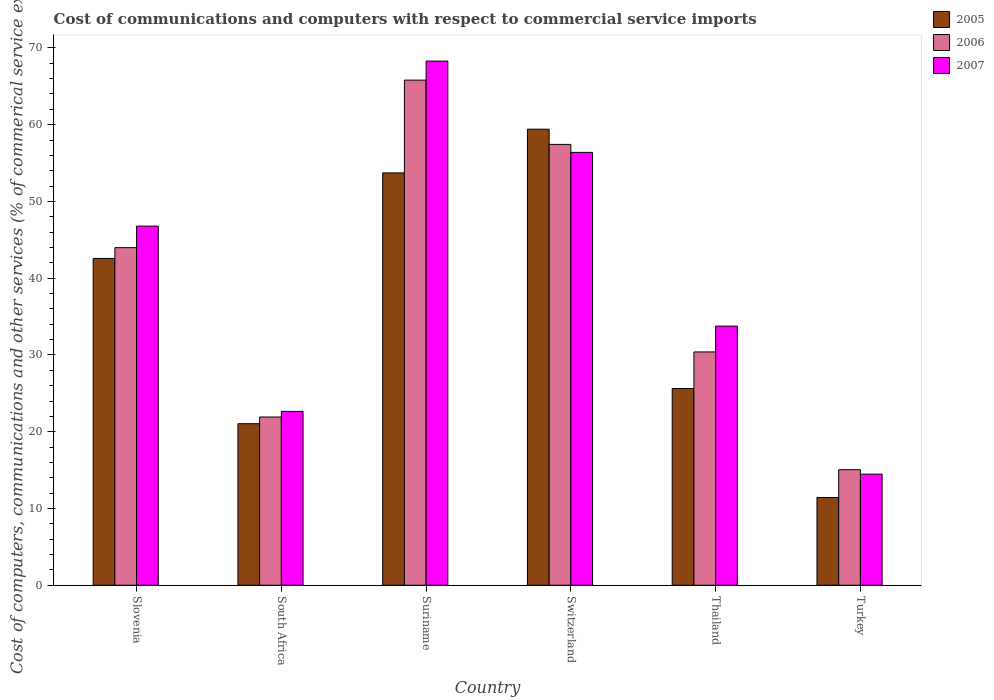What is the label of the 6th group of bars from the left?
Provide a succinct answer. Turkey. In how many cases, is the number of bars for a given country not equal to the number of legend labels?
Your answer should be very brief. 0. What is the cost of communications and computers in 2007 in Suriname?
Provide a succinct answer. 68.28. Across all countries, what is the maximum cost of communications and computers in 2007?
Ensure brevity in your answer.  68.28. Across all countries, what is the minimum cost of communications and computers in 2006?
Keep it short and to the point. 15.05. In which country was the cost of communications and computers in 2006 maximum?
Keep it short and to the point. Suriname. In which country was the cost of communications and computers in 2007 minimum?
Your answer should be very brief. Turkey. What is the total cost of communications and computers in 2007 in the graph?
Your response must be concise. 242.33. What is the difference between the cost of communications and computers in 2005 in Slovenia and that in Turkey?
Ensure brevity in your answer.  31.15. What is the difference between the cost of communications and computers in 2005 in South Africa and the cost of communications and computers in 2006 in Thailand?
Offer a very short reply. -9.35. What is the average cost of communications and computers in 2007 per country?
Your answer should be very brief. 40.39. What is the difference between the cost of communications and computers of/in 2005 and cost of communications and computers of/in 2007 in South Africa?
Offer a very short reply. -1.6. In how many countries, is the cost of communications and computers in 2007 greater than 64 %?
Your answer should be compact. 1. What is the ratio of the cost of communications and computers in 2006 in Slovenia to that in Turkey?
Ensure brevity in your answer.  2.92. Is the cost of communications and computers in 2007 in Slovenia less than that in Turkey?
Provide a short and direct response. No. Is the difference between the cost of communications and computers in 2005 in Slovenia and Thailand greater than the difference between the cost of communications and computers in 2007 in Slovenia and Thailand?
Your response must be concise. Yes. What is the difference between the highest and the second highest cost of communications and computers in 2006?
Ensure brevity in your answer.  21.82. What is the difference between the highest and the lowest cost of communications and computers in 2005?
Your answer should be very brief. 47.98. In how many countries, is the cost of communications and computers in 2007 greater than the average cost of communications and computers in 2007 taken over all countries?
Offer a terse response. 3. Is it the case that in every country, the sum of the cost of communications and computers in 2006 and cost of communications and computers in 2007 is greater than the cost of communications and computers in 2005?
Your answer should be compact. Yes. How many bars are there?
Make the answer very short. 18. Does the graph contain grids?
Ensure brevity in your answer.  No. Where does the legend appear in the graph?
Offer a very short reply. Top right. What is the title of the graph?
Make the answer very short. Cost of communications and computers with respect to commercial service imports. Does "1961" appear as one of the legend labels in the graph?
Your answer should be very brief. No. What is the label or title of the X-axis?
Your response must be concise. Country. What is the label or title of the Y-axis?
Make the answer very short. Cost of computers, communications and other services (% of commerical service exports). What is the Cost of computers, communications and other services (% of commerical service exports) in 2005 in Slovenia?
Provide a succinct answer. 42.57. What is the Cost of computers, communications and other services (% of commerical service exports) in 2006 in Slovenia?
Your answer should be very brief. 43.98. What is the Cost of computers, communications and other services (% of commerical service exports) in 2007 in Slovenia?
Offer a terse response. 46.78. What is the Cost of computers, communications and other services (% of commerical service exports) of 2005 in South Africa?
Keep it short and to the point. 21.04. What is the Cost of computers, communications and other services (% of commerical service exports) of 2006 in South Africa?
Your answer should be compact. 21.92. What is the Cost of computers, communications and other services (% of commerical service exports) in 2007 in South Africa?
Your answer should be compact. 22.65. What is the Cost of computers, communications and other services (% of commerical service exports) of 2005 in Suriname?
Provide a succinct answer. 53.71. What is the Cost of computers, communications and other services (% of commerical service exports) of 2006 in Suriname?
Your response must be concise. 65.8. What is the Cost of computers, communications and other services (% of commerical service exports) of 2007 in Suriname?
Give a very brief answer. 68.28. What is the Cost of computers, communications and other services (% of commerical service exports) of 2005 in Switzerland?
Make the answer very short. 59.41. What is the Cost of computers, communications and other services (% of commerical service exports) in 2006 in Switzerland?
Your answer should be compact. 57.43. What is the Cost of computers, communications and other services (% of commerical service exports) in 2007 in Switzerland?
Make the answer very short. 56.39. What is the Cost of computers, communications and other services (% of commerical service exports) of 2005 in Thailand?
Give a very brief answer. 25.63. What is the Cost of computers, communications and other services (% of commerical service exports) of 2006 in Thailand?
Offer a very short reply. 30.39. What is the Cost of computers, communications and other services (% of commerical service exports) in 2007 in Thailand?
Make the answer very short. 33.76. What is the Cost of computers, communications and other services (% of commerical service exports) in 2005 in Turkey?
Your response must be concise. 11.43. What is the Cost of computers, communications and other services (% of commerical service exports) in 2006 in Turkey?
Keep it short and to the point. 15.05. What is the Cost of computers, communications and other services (% of commerical service exports) in 2007 in Turkey?
Provide a short and direct response. 14.47. Across all countries, what is the maximum Cost of computers, communications and other services (% of commerical service exports) in 2005?
Your answer should be compact. 59.41. Across all countries, what is the maximum Cost of computers, communications and other services (% of commerical service exports) of 2006?
Your answer should be very brief. 65.8. Across all countries, what is the maximum Cost of computers, communications and other services (% of commerical service exports) of 2007?
Your response must be concise. 68.28. Across all countries, what is the minimum Cost of computers, communications and other services (% of commerical service exports) of 2005?
Offer a terse response. 11.43. Across all countries, what is the minimum Cost of computers, communications and other services (% of commerical service exports) of 2006?
Your answer should be compact. 15.05. Across all countries, what is the minimum Cost of computers, communications and other services (% of commerical service exports) of 2007?
Give a very brief answer. 14.47. What is the total Cost of computers, communications and other services (% of commerical service exports) of 2005 in the graph?
Make the answer very short. 213.79. What is the total Cost of computers, communications and other services (% of commerical service exports) in 2006 in the graph?
Your answer should be very brief. 234.57. What is the total Cost of computers, communications and other services (% of commerical service exports) in 2007 in the graph?
Keep it short and to the point. 242.33. What is the difference between the Cost of computers, communications and other services (% of commerical service exports) in 2005 in Slovenia and that in South Africa?
Offer a very short reply. 21.53. What is the difference between the Cost of computers, communications and other services (% of commerical service exports) of 2006 in Slovenia and that in South Africa?
Provide a short and direct response. 22.06. What is the difference between the Cost of computers, communications and other services (% of commerical service exports) in 2007 in Slovenia and that in South Africa?
Provide a short and direct response. 24.14. What is the difference between the Cost of computers, communications and other services (% of commerical service exports) in 2005 in Slovenia and that in Suriname?
Provide a short and direct response. -11.14. What is the difference between the Cost of computers, communications and other services (% of commerical service exports) in 2006 in Slovenia and that in Suriname?
Give a very brief answer. -21.82. What is the difference between the Cost of computers, communications and other services (% of commerical service exports) in 2007 in Slovenia and that in Suriname?
Ensure brevity in your answer.  -21.5. What is the difference between the Cost of computers, communications and other services (% of commerical service exports) in 2005 in Slovenia and that in Switzerland?
Give a very brief answer. -16.83. What is the difference between the Cost of computers, communications and other services (% of commerical service exports) of 2006 in Slovenia and that in Switzerland?
Keep it short and to the point. -13.45. What is the difference between the Cost of computers, communications and other services (% of commerical service exports) of 2007 in Slovenia and that in Switzerland?
Provide a short and direct response. -9.61. What is the difference between the Cost of computers, communications and other services (% of commerical service exports) in 2005 in Slovenia and that in Thailand?
Offer a terse response. 16.94. What is the difference between the Cost of computers, communications and other services (% of commerical service exports) in 2006 in Slovenia and that in Thailand?
Your answer should be very brief. 13.59. What is the difference between the Cost of computers, communications and other services (% of commerical service exports) of 2007 in Slovenia and that in Thailand?
Make the answer very short. 13.02. What is the difference between the Cost of computers, communications and other services (% of commerical service exports) of 2005 in Slovenia and that in Turkey?
Offer a very short reply. 31.15. What is the difference between the Cost of computers, communications and other services (% of commerical service exports) of 2006 in Slovenia and that in Turkey?
Your answer should be compact. 28.93. What is the difference between the Cost of computers, communications and other services (% of commerical service exports) of 2007 in Slovenia and that in Turkey?
Give a very brief answer. 32.31. What is the difference between the Cost of computers, communications and other services (% of commerical service exports) in 2005 in South Africa and that in Suriname?
Your answer should be compact. -32.67. What is the difference between the Cost of computers, communications and other services (% of commerical service exports) of 2006 in South Africa and that in Suriname?
Offer a terse response. -43.89. What is the difference between the Cost of computers, communications and other services (% of commerical service exports) of 2007 in South Africa and that in Suriname?
Your response must be concise. -45.64. What is the difference between the Cost of computers, communications and other services (% of commerical service exports) of 2005 in South Africa and that in Switzerland?
Make the answer very short. -38.37. What is the difference between the Cost of computers, communications and other services (% of commerical service exports) in 2006 in South Africa and that in Switzerland?
Your answer should be very brief. -35.51. What is the difference between the Cost of computers, communications and other services (% of commerical service exports) of 2007 in South Africa and that in Switzerland?
Offer a very short reply. -33.74. What is the difference between the Cost of computers, communications and other services (% of commerical service exports) of 2005 in South Africa and that in Thailand?
Provide a succinct answer. -4.59. What is the difference between the Cost of computers, communications and other services (% of commerical service exports) in 2006 in South Africa and that in Thailand?
Provide a succinct answer. -8.48. What is the difference between the Cost of computers, communications and other services (% of commerical service exports) in 2007 in South Africa and that in Thailand?
Your answer should be compact. -11.11. What is the difference between the Cost of computers, communications and other services (% of commerical service exports) in 2005 in South Africa and that in Turkey?
Your response must be concise. 9.62. What is the difference between the Cost of computers, communications and other services (% of commerical service exports) in 2006 in South Africa and that in Turkey?
Provide a succinct answer. 6.87. What is the difference between the Cost of computers, communications and other services (% of commerical service exports) of 2007 in South Africa and that in Turkey?
Your response must be concise. 8.18. What is the difference between the Cost of computers, communications and other services (% of commerical service exports) in 2005 in Suriname and that in Switzerland?
Give a very brief answer. -5.69. What is the difference between the Cost of computers, communications and other services (% of commerical service exports) of 2006 in Suriname and that in Switzerland?
Give a very brief answer. 8.37. What is the difference between the Cost of computers, communications and other services (% of commerical service exports) in 2007 in Suriname and that in Switzerland?
Give a very brief answer. 11.89. What is the difference between the Cost of computers, communications and other services (% of commerical service exports) of 2005 in Suriname and that in Thailand?
Keep it short and to the point. 28.09. What is the difference between the Cost of computers, communications and other services (% of commerical service exports) in 2006 in Suriname and that in Thailand?
Offer a terse response. 35.41. What is the difference between the Cost of computers, communications and other services (% of commerical service exports) of 2007 in Suriname and that in Thailand?
Your answer should be very brief. 34.52. What is the difference between the Cost of computers, communications and other services (% of commerical service exports) of 2005 in Suriname and that in Turkey?
Provide a short and direct response. 42.29. What is the difference between the Cost of computers, communications and other services (% of commerical service exports) in 2006 in Suriname and that in Turkey?
Offer a very short reply. 50.75. What is the difference between the Cost of computers, communications and other services (% of commerical service exports) of 2007 in Suriname and that in Turkey?
Keep it short and to the point. 53.81. What is the difference between the Cost of computers, communications and other services (% of commerical service exports) in 2005 in Switzerland and that in Thailand?
Your response must be concise. 33.78. What is the difference between the Cost of computers, communications and other services (% of commerical service exports) in 2006 in Switzerland and that in Thailand?
Ensure brevity in your answer.  27.04. What is the difference between the Cost of computers, communications and other services (% of commerical service exports) in 2007 in Switzerland and that in Thailand?
Give a very brief answer. 22.63. What is the difference between the Cost of computers, communications and other services (% of commerical service exports) of 2005 in Switzerland and that in Turkey?
Keep it short and to the point. 47.98. What is the difference between the Cost of computers, communications and other services (% of commerical service exports) in 2006 in Switzerland and that in Turkey?
Keep it short and to the point. 42.38. What is the difference between the Cost of computers, communications and other services (% of commerical service exports) of 2007 in Switzerland and that in Turkey?
Your answer should be compact. 41.92. What is the difference between the Cost of computers, communications and other services (% of commerical service exports) of 2005 in Thailand and that in Turkey?
Provide a succinct answer. 14.2. What is the difference between the Cost of computers, communications and other services (% of commerical service exports) of 2006 in Thailand and that in Turkey?
Keep it short and to the point. 15.34. What is the difference between the Cost of computers, communications and other services (% of commerical service exports) of 2007 in Thailand and that in Turkey?
Your response must be concise. 19.29. What is the difference between the Cost of computers, communications and other services (% of commerical service exports) in 2005 in Slovenia and the Cost of computers, communications and other services (% of commerical service exports) in 2006 in South Africa?
Offer a terse response. 20.66. What is the difference between the Cost of computers, communications and other services (% of commerical service exports) in 2005 in Slovenia and the Cost of computers, communications and other services (% of commerical service exports) in 2007 in South Africa?
Your answer should be very brief. 19.93. What is the difference between the Cost of computers, communications and other services (% of commerical service exports) of 2006 in Slovenia and the Cost of computers, communications and other services (% of commerical service exports) of 2007 in South Africa?
Your response must be concise. 21.33. What is the difference between the Cost of computers, communications and other services (% of commerical service exports) in 2005 in Slovenia and the Cost of computers, communications and other services (% of commerical service exports) in 2006 in Suriname?
Provide a short and direct response. -23.23. What is the difference between the Cost of computers, communications and other services (% of commerical service exports) of 2005 in Slovenia and the Cost of computers, communications and other services (% of commerical service exports) of 2007 in Suriname?
Your response must be concise. -25.71. What is the difference between the Cost of computers, communications and other services (% of commerical service exports) in 2006 in Slovenia and the Cost of computers, communications and other services (% of commerical service exports) in 2007 in Suriname?
Provide a succinct answer. -24.3. What is the difference between the Cost of computers, communications and other services (% of commerical service exports) of 2005 in Slovenia and the Cost of computers, communications and other services (% of commerical service exports) of 2006 in Switzerland?
Provide a short and direct response. -14.85. What is the difference between the Cost of computers, communications and other services (% of commerical service exports) of 2005 in Slovenia and the Cost of computers, communications and other services (% of commerical service exports) of 2007 in Switzerland?
Provide a short and direct response. -13.81. What is the difference between the Cost of computers, communications and other services (% of commerical service exports) in 2006 in Slovenia and the Cost of computers, communications and other services (% of commerical service exports) in 2007 in Switzerland?
Provide a succinct answer. -12.41. What is the difference between the Cost of computers, communications and other services (% of commerical service exports) of 2005 in Slovenia and the Cost of computers, communications and other services (% of commerical service exports) of 2006 in Thailand?
Give a very brief answer. 12.18. What is the difference between the Cost of computers, communications and other services (% of commerical service exports) in 2005 in Slovenia and the Cost of computers, communications and other services (% of commerical service exports) in 2007 in Thailand?
Give a very brief answer. 8.82. What is the difference between the Cost of computers, communications and other services (% of commerical service exports) of 2006 in Slovenia and the Cost of computers, communications and other services (% of commerical service exports) of 2007 in Thailand?
Ensure brevity in your answer.  10.22. What is the difference between the Cost of computers, communications and other services (% of commerical service exports) of 2005 in Slovenia and the Cost of computers, communications and other services (% of commerical service exports) of 2006 in Turkey?
Provide a succinct answer. 27.52. What is the difference between the Cost of computers, communications and other services (% of commerical service exports) of 2005 in Slovenia and the Cost of computers, communications and other services (% of commerical service exports) of 2007 in Turkey?
Ensure brevity in your answer.  28.1. What is the difference between the Cost of computers, communications and other services (% of commerical service exports) of 2006 in Slovenia and the Cost of computers, communications and other services (% of commerical service exports) of 2007 in Turkey?
Your response must be concise. 29.51. What is the difference between the Cost of computers, communications and other services (% of commerical service exports) in 2005 in South Africa and the Cost of computers, communications and other services (% of commerical service exports) in 2006 in Suriname?
Your answer should be compact. -44.76. What is the difference between the Cost of computers, communications and other services (% of commerical service exports) in 2005 in South Africa and the Cost of computers, communications and other services (% of commerical service exports) in 2007 in Suriname?
Give a very brief answer. -47.24. What is the difference between the Cost of computers, communications and other services (% of commerical service exports) in 2006 in South Africa and the Cost of computers, communications and other services (% of commerical service exports) in 2007 in Suriname?
Keep it short and to the point. -46.37. What is the difference between the Cost of computers, communications and other services (% of commerical service exports) in 2005 in South Africa and the Cost of computers, communications and other services (% of commerical service exports) in 2006 in Switzerland?
Ensure brevity in your answer.  -36.39. What is the difference between the Cost of computers, communications and other services (% of commerical service exports) of 2005 in South Africa and the Cost of computers, communications and other services (% of commerical service exports) of 2007 in Switzerland?
Provide a succinct answer. -35.35. What is the difference between the Cost of computers, communications and other services (% of commerical service exports) of 2006 in South Africa and the Cost of computers, communications and other services (% of commerical service exports) of 2007 in Switzerland?
Make the answer very short. -34.47. What is the difference between the Cost of computers, communications and other services (% of commerical service exports) in 2005 in South Africa and the Cost of computers, communications and other services (% of commerical service exports) in 2006 in Thailand?
Offer a terse response. -9.35. What is the difference between the Cost of computers, communications and other services (% of commerical service exports) in 2005 in South Africa and the Cost of computers, communications and other services (% of commerical service exports) in 2007 in Thailand?
Keep it short and to the point. -12.72. What is the difference between the Cost of computers, communications and other services (% of commerical service exports) of 2006 in South Africa and the Cost of computers, communications and other services (% of commerical service exports) of 2007 in Thailand?
Make the answer very short. -11.84. What is the difference between the Cost of computers, communications and other services (% of commerical service exports) of 2005 in South Africa and the Cost of computers, communications and other services (% of commerical service exports) of 2006 in Turkey?
Your response must be concise. 5.99. What is the difference between the Cost of computers, communications and other services (% of commerical service exports) of 2005 in South Africa and the Cost of computers, communications and other services (% of commerical service exports) of 2007 in Turkey?
Ensure brevity in your answer.  6.57. What is the difference between the Cost of computers, communications and other services (% of commerical service exports) of 2006 in South Africa and the Cost of computers, communications and other services (% of commerical service exports) of 2007 in Turkey?
Give a very brief answer. 7.45. What is the difference between the Cost of computers, communications and other services (% of commerical service exports) of 2005 in Suriname and the Cost of computers, communications and other services (% of commerical service exports) of 2006 in Switzerland?
Ensure brevity in your answer.  -3.71. What is the difference between the Cost of computers, communications and other services (% of commerical service exports) in 2005 in Suriname and the Cost of computers, communications and other services (% of commerical service exports) in 2007 in Switzerland?
Your response must be concise. -2.67. What is the difference between the Cost of computers, communications and other services (% of commerical service exports) of 2006 in Suriname and the Cost of computers, communications and other services (% of commerical service exports) of 2007 in Switzerland?
Your response must be concise. 9.41. What is the difference between the Cost of computers, communications and other services (% of commerical service exports) of 2005 in Suriname and the Cost of computers, communications and other services (% of commerical service exports) of 2006 in Thailand?
Offer a very short reply. 23.32. What is the difference between the Cost of computers, communications and other services (% of commerical service exports) in 2005 in Suriname and the Cost of computers, communications and other services (% of commerical service exports) in 2007 in Thailand?
Make the answer very short. 19.96. What is the difference between the Cost of computers, communications and other services (% of commerical service exports) in 2006 in Suriname and the Cost of computers, communications and other services (% of commerical service exports) in 2007 in Thailand?
Your response must be concise. 32.04. What is the difference between the Cost of computers, communications and other services (% of commerical service exports) in 2005 in Suriname and the Cost of computers, communications and other services (% of commerical service exports) in 2006 in Turkey?
Your response must be concise. 38.67. What is the difference between the Cost of computers, communications and other services (% of commerical service exports) of 2005 in Suriname and the Cost of computers, communications and other services (% of commerical service exports) of 2007 in Turkey?
Your response must be concise. 39.24. What is the difference between the Cost of computers, communications and other services (% of commerical service exports) of 2006 in Suriname and the Cost of computers, communications and other services (% of commerical service exports) of 2007 in Turkey?
Your response must be concise. 51.33. What is the difference between the Cost of computers, communications and other services (% of commerical service exports) of 2005 in Switzerland and the Cost of computers, communications and other services (% of commerical service exports) of 2006 in Thailand?
Offer a very short reply. 29.01. What is the difference between the Cost of computers, communications and other services (% of commerical service exports) in 2005 in Switzerland and the Cost of computers, communications and other services (% of commerical service exports) in 2007 in Thailand?
Provide a short and direct response. 25.65. What is the difference between the Cost of computers, communications and other services (% of commerical service exports) in 2006 in Switzerland and the Cost of computers, communications and other services (% of commerical service exports) in 2007 in Thailand?
Provide a short and direct response. 23.67. What is the difference between the Cost of computers, communications and other services (% of commerical service exports) of 2005 in Switzerland and the Cost of computers, communications and other services (% of commerical service exports) of 2006 in Turkey?
Make the answer very short. 44.36. What is the difference between the Cost of computers, communications and other services (% of commerical service exports) in 2005 in Switzerland and the Cost of computers, communications and other services (% of commerical service exports) in 2007 in Turkey?
Offer a very short reply. 44.94. What is the difference between the Cost of computers, communications and other services (% of commerical service exports) of 2006 in Switzerland and the Cost of computers, communications and other services (% of commerical service exports) of 2007 in Turkey?
Your response must be concise. 42.96. What is the difference between the Cost of computers, communications and other services (% of commerical service exports) of 2005 in Thailand and the Cost of computers, communications and other services (% of commerical service exports) of 2006 in Turkey?
Make the answer very short. 10.58. What is the difference between the Cost of computers, communications and other services (% of commerical service exports) of 2005 in Thailand and the Cost of computers, communications and other services (% of commerical service exports) of 2007 in Turkey?
Offer a terse response. 11.16. What is the difference between the Cost of computers, communications and other services (% of commerical service exports) in 2006 in Thailand and the Cost of computers, communications and other services (% of commerical service exports) in 2007 in Turkey?
Provide a short and direct response. 15.92. What is the average Cost of computers, communications and other services (% of commerical service exports) of 2005 per country?
Your answer should be compact. 35.63. What is the average Cost of computers, communications and other services (% of commerical service exports) in 2006 per country?
Give a very brief answer. 39.09. What is the average Cost of computers, communications and other services (% of commerical service exports) in 2007 per country?
Ensure brevity in your answer.  40.39. What is the difference between the Cost of computers, communications and other services (% of commerical service exports) in 2005 and Cost of computers, communications and other services (% of commerical service exports) in 2006 in Slovenia?
Your answer should be very brief. -1.4. What is the difference between the Cost of computers, communications and other services (% of commerical service exports) of 2005 and Cost of computers, communications and other services (% of commerical service exports) of 2007 in Slovenia?
Keep it short and to the point. -4.21. What is the difference between the Cost of computers, communications and other services (% of commerical service exports) in 2006 and Cost of computers, communications and other services (% of commerical service exports) in 2007 in Slovenia?
Provide a succinct answer. -2.8. What is the difference between the Cost of computers, communications and other services (% of commerical service exports) of 2005 and Cost of computers, communications and other services (% of commerical service exports) of 2006 in South Africa?
Offer a terse response. -0.87. What is the difference between the Cost of computers, communications and other services (% of commerical service exports) of 2005 and Cost of computers, communications and other services (% of commerical service exports) of 2007 in South Africa?
Your answer should be compact. -1.6. What is the difference between the Cost of computers, communications and other services (% of commerical service exports) of 2006 and Cost of computers, communications and other services (% of commerical service exports) of 2007 in South Africa?
Ensure brevity in your answer.  -0.73. What is the difference between the Cost of computers, communications and other services (% of commerical service exports) of 2005 and Cost of computers, communications and other services (% of commerical service exports) of 2006 in Suriname?
Your response must be concise. -12.09. What is the difference between the Cost of computers, communications and other services (% of commerical service exports) of 2005 and Cost of computers, communications and other services (% of commerical service exports) of 2007 in Suriname?
Offer a very short reply. -14.57. What is the difference between the Cost of computers, communications and other services (% of commerical service exports) of 2006 and Cost of computers, communications and other services (% of commerical service exports) of 2007 in Suriname?
Your response must be concise. -2.48. What is the difference between the Cost of computers, communications and other services (% of commerical service exports) in 2005 and Cost of computers, communications and other services (% of commerical service exports) in 2006 in Switzerland?
Provide a succinct answer. 1.98. What is the difference between the Cost of computers, communications and other services (% of commerical service exports) in 2005 and Cost of computers, communications and other services (% of commerical service exports) in 2007 in Switzerland?
Ensure brevity in your answer.  3.02. What is the difference between the Cost of computers, communications and other services (% of commerical service exports) of 2006 and Cost of computers, communications and other services (% of commerical service exports) of 2007 in Switzerland?
Make the answer very short. 1.04. What is the difference between the Cost of computers, communications and other services (% of commerical service exports) in 2005 and Cost of computers, communications and other services (% of commerical service exports) in 2006 in Thailand?
Provide a short and direct response. -4.76. What is the difference between the Cost of computers, communications and other services (% of commerical service exports) of 2005 and Cost of computers, communications and other services (% of commerical service exports) of 2007 in Thailand?
Offer a terse response. -8.13. What is the difference between the Cost of computers, communications and other services (% of commerical service exports) in 2006 and Cost of computers, communications and other services (% of commerical service exports) in 2007 in Thailand?
Your answer should be very brief. -3.37. What is the difference between the Cost of computers, communications and other services (% of commerical service exports) in 2005 and Cost of computers, communications and other services (% of commerical service exports) in 2006 in Turkey?
Ensure brevity in your answer.  -3.62. What is the difference between the Cost of computers, communications and other services (% of commerical service exports) of 2005 and Cost of computers, communications and other services (% of commerical service exports) of 2007 in Turkey?
Keep it short and to the point. -3.05. What is the difference between the Cost of computers, communications and other services (% of commerical service exports) of 2006 and Cost of computers, communications and other services (% of commerical service exports) of 2007 in Turkey?
Make the answer very short. 0.58. What is the ratio of the Cost of computers, communications and other services (% of commerical service exports) in 2005 in Slovenia to that in South Africa?
Ensure brevity in your answer.  2.02. What is the ratio of the Cost of computers, communications and other services (% of commerical service exports) of 2006 in Slovenia to that in South Africa?
Keep it short and to the point. 2.01. What is the ratio of the Cost of computers, communications and other services (% of commerical service exports) of 2007 in Slovenia to that in South Africa?
Keep it short and to the point. 2.07. What is the ratio of the Cost of computers, communications and other services (% of commerical service exports) in 2005 in Slovenia to that in Suriname?
Your response must be concise. 0.79. What is the ratio of the Cost of computers, communications and other services (% of commerical service exports) of 2006 in Slovenia to that in Suriname?
Your answer should be compact. 0.67. What is the ratio of the Cost of computers, communications and other services (% of commerical service exports) in 2007 in Slovenia to that in Suriname?
Your response must be concise. 0.69. What is the ratio of the Cost of computers, communications and other services (% of commerical service exports) in 2005 in Slovenia to that in Switzerland?
Your answer should be compact. 0.72. What is the ratio of the Cost of computers, communications and other services (% of commerical service exports) in 2006 in Slovenia to that in Switzerland?
Your answer should be very brief. 0.77. What is the ratio of the Cost of computers, communications and other services (% of commerical service exports) in 2007 in Slovenia to that in Switzerland?
Ensure brevity in your answer.  0.83. What is the ratio of the Cost of computers, communications and other services (% of commerical service exports) in 2005 in Slovenia to that in Thailand?
Make the answer very short. 1.66. What is the ratio of the Cost of computers, communications and other services (% of commerical service exports) in 2006 in Slovenia to that in Thailand?
Provide a succinct answer. 1.45. What is the ratio of the Cost of computers, communications and other services (% of commerical service exports) of 2007 in Slovenia to that in Thailand?
Make the answer very short. 1.39. What is the ratio of the Cost of computers, communications and other services (% of commerical service exports) of 2005 in Slovenia to that in Turkey?
Keep it short and to the point. 3.73. What is the ratio of the Cost of computers, communications and other services (% of commerical service exports) in 2006 in Slovenia to that in Turkey?
Make the answer very short. 2.92. What is the ratio of the Cost of computers, communications and other services (% of commerical service exports) of 2007 in Slovenia to that in Turkey?
Keep it short and to the point. 3.23. What is the ratio of the Cost of computers, communications and other services (% of commerical service exports) in 2005 in South Africa to that in Suriname?
Offer a very short reply. 0.39. What is the ratio of the Cost of computers, communications and other services (% of commerical service exports) in 2006 in South Africa to that in Suriname?
Keep it short and to the point. 0.33. What is the ratio of the Cost of computers, communications and other services (% of commerical service exports) of 2007 in South Africa to that in Suriname?
Provide a succinct answer. 0.33. What is the ratio of the Cost of computers, communications and other services (% of commerical service exports) of 2005 in South Africa to that in Switzerland?
Provide a short and direct response. 0.35. What is the ratio of the Cost of computers, communications and other services (% of commerical service exports) in 2006 in South Africa to that in Switzerland?
Offer a terse response. 0.38. What is the ratio of the Cost of computers, communications and other services (% of commerical service exports) in 2007 in South Africa to that in Switzerland?
Your answer should be compact. 0.4. What is the ratio of the Cost of computers, communications and other services (% of commerical service exports) in 2005 in South Africa to that in Thailand?
Keep it short and to the point. 0.82. What is the ratio of the Cost of computers, communications and other services (% of commerical service exports) of 2006 in South Africa to that in Thailand?
Ensure brevity in your answer.  0.72. What is the ratio of the Cost of computers, communications and other services (% of commerical service exports) of 2007 in South Africa to that in Thailand?
Provide a succinct answer. 0.67. What is the ratio of the Cost of computers, communications and other services (% of commerical service exports) in 2005 in South Africa to that in Turkey?
Offer a very short reply. 1.84. What is the ratio of the Cost of computers, communications and other services (% of commerical service exports) of 2006 in South Africa to that in Turkey?
Give a very brief answer. 1.46. What is the ratio of the Cost of computers, communications and other services (% of commerical service exports) in 2007 in South Africa to that in Turkey?
Your response must be concise. 1.56. What is the ratio of the Cost of computers, communications and other services (% of commerical service exports) of 2005 in Suriname to that in Switzerland?
Your response must be concise. 0.9. What is the ratio of the Cost of computers, communications and other services (% of commerical service exports) in 2006 in Suriname to that in Switzerland?
Give a very brief answer. 1.15. What is the ratio of the Cost of computers, communications and other services (% of commerical service exports) of 2007 in Suriname to that in Switzerland?
Give a very brief answer. 1.21. What is the ratio of the Cost of computers, communications and other services (% of commerical service exports) in 2005 in Suriname to that in Thailand?
Ensure brevity in your answer.  2.1. What is the ratio of the Cost of computers, communications and other services (% of commerical service exports) of 2006 in Suriname to that in Thailand?
Provide a short and direct response. 2.17. What is the ratio of the Cost of computers, communications and other services (% of commerical service exports) of 2007 in Suriname to that in Thailand?
Make the answer very short. 2.02. What is the ratio of the Cost of computers, communications and other services (% of commerical service exports) in 2005 in Suriname to that in Turkey?
Your response must be concise. 4.7. What is the ratio of the Cost of computers, communications and other services (% of commerical service exports) of 2006 in Suriname to that in Turkey?
Your response must be concise. 4.37. What is the ratio of the Cost of computers, communications and other services (% of commerical service exports) of 2007 in Suriname to that in Turkey?
Make the answer very short. 4.72. What is the ratio of the Cost of computers, communications and other services (% of commerical service exports) in 2005 in Switzerland to that in Thailand?
Provide a succinct answer. 2.32. What is the ratio of the Cost of computers, communications and other services (% of commerical service exports) of 2006 in Switzerland to that in Thailand?
Offer a terse response. 1.89. What is the ratio of the Cost of computers, communications and other services (% of commerical service exports) of 2007 in Switzerland to that in Thailand?
Make the answer very short. 1.67. What is the ratio of the Cost of computers, communications and other services (% of commerical service exports) in 2005 in Switzerland to that in Turkey?
Make the answer very short. 5.2. What is the ratio of the Cost of computers, communications and other services (% of commerical service exports) in 2006 in Switzerland to that in Turkey?
Your response must be concise. 3.82. What is the ratio of the Cost of computers, communications and other services (% of commerical service exports) in 2007 in Switzerland to that in Turkey?
Offer a terse response. 3.9. What is the ratio of the Cost of computers, communications and other services (% of commerical service exports) in 2005 in Thailand to that in Turkey?
Provide a short and direct response. 2.24. What is the ratio of the Cost of computers, communications and other services (% of commerical service exports) of 2006 in Thailand to that in Turkey?
Provide a short and direct response. 2.02. What is the ratio of the Cost of computers, communications and other services (% of commerical service exports) in 2007 in Thailand to that in Turkey?
Ensure brevity in your answer.  2.33. What is the difference between the highest and the second highest Cost of computers, communications and other services (% of commerical service exports) of 2005?
Your answer should be compact. 5.69. What is the difference between the highest and the second highest Cost of computers, communications and other services (% of commerical service exports) of 2006?
Provide a succinct answer. 8.37. What is the difference between the highest and the second highest Cost of computers, communications and other services (% of commerical service exports) in 2007?
Your response must be concise. 11.89. What is the difference between the highest and the lowest Cost of computers, communications and other services (% of commerical service exports) in 2005?
Keep it short and to the point. 47.98. What is the difference between the highest and the lowest Cost of computers, communications and other services (% of commerical service exports) in 2006?
Your answer should be very brief. 50.75. What is the difference between the highest and the lowest Cost of computers, communications and other services (% of commerical service exports) in 2007?
Your answer should be very brief. 53.81. 